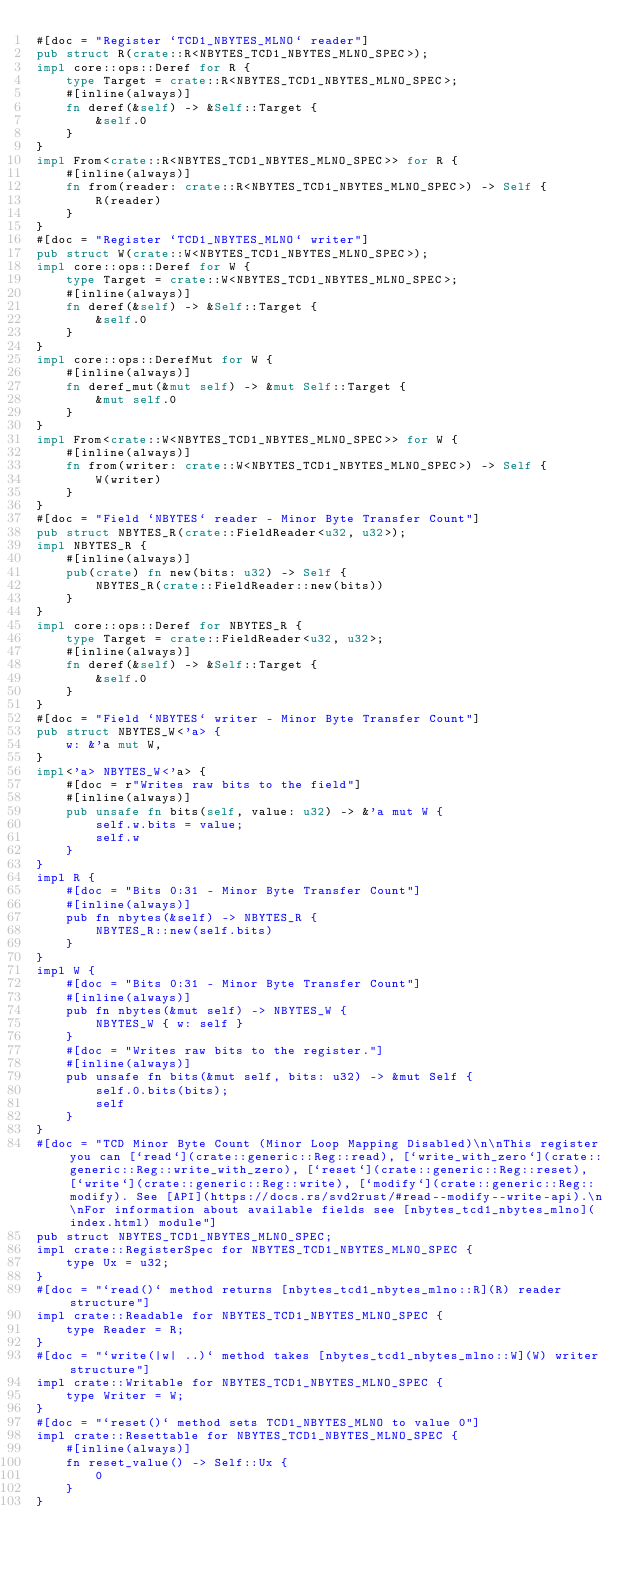Convert code to text. <code><loc_0><loc_0><loc_500><loc_500><_Rust_>#[doc = "Register `TCD1_NBYTES_MLNO` reader"]
pub struct R(crate::R<NBYTES_TCD1_NBYTES_MLNO_SPEC>);
impl core::ops::Deref for R {
    type Target = crate::R<NBYTES_TCD1_NBYTES_MLNO_SPEC>;
    #[inline(always)]
    fn deref(&self) -> &Self::Target {
        &self.0
    }
}
impl From<crate::R<NBYTES_TCD1_NBYTES_MLNO_SPEC>> for R {
    #[inline(always)]
    fn from(reader: crate::R<NBYTES_TCD1_NBYTES_MLNO_SPEC>) -> Self {
        R(reader)
    }
}
#[doc = "Register `TCD1_NBYTES_MLNO` writer"]
pub struct W(crate::W<NBYTES_TCD1_NBYTES_MLNO_SPEC>);
impl core::ops::Deref for W {
    type Target = crate::W<NBYTES_TCD1_NBYTES_MLNO_SPEC>;
    #[inline(always)]
    fn deref(&self) -> &Self::Target {
        &self.0
    }
}
impl core::ops::DerefMut for W {
    #[inline(always)]
    fn deref_mut(&mut self) -> &mut Self::Target {
        &mut self.0
    }
}
impl From<crate::W<NBYTES_TCD1_NBYTES_MLNO_SPEC>> for W {
    #[inline(always)]
    fn from(writer: crate::W<NBYTES_TCD1_NBYTES_MLNO_SPEC>) -> Self {
        W(writer)
    }
}
#[doc = "Field `NBYTES` reader - Minor Byte Transfer Count"]
pub struct NBYTES_R(crate::FieldReader<u32, u32>);
impl NBYTES_R {
    #[inline(always)]
    pub(crate) fn new(bits: u32) -> Self {
        NBYTES_R(crate::FieldReader::new(bits))
    }
}
impl core::ops::Deref for NBYTES_R {
    type Target = crate::FieldReader<u32, u32>;
    #[inline(always)]
    fn deref(&self) -> &Self::Target {
        &self.0
    }
}
#[doc = "Field `NBYTES` writer - Minor Byte Transfer Count"]
pub struct NBYTES_W<'a> {
    w: &'a mut W,
}
impl<'a> NBYTES_W<'a> {
    #[doc = r"Writes raw bits to the field"]
    #[inline(always)]
    pub unsafe fn bits(self, value: u32) -> &'a mut W {
        self.w.bits = value;
        self.w
    }
}
impl R {
    #[doc = "Bits 0:31 - Minor Byte Transfer Count"]
    #[inline(always)]
    pub fn nbytes(&self) -> NBYTES_R {
        NBYTES_R::new(self.bits)
    }
}
impl W {
    #[doc = "Bits 0:31 - Minor Byte Transfer Count"]
    #[inline(always)]
    pub fn nbytes(&mut self) -> NBYTES_W {
        NBYTES_W { w: self }
    }
    #[doc = "Writes raw bits to the register."]
    #[inline(always)]
    pub unsafe fn bits(&mut self, bits: u32) -> &mut Self {
        self.0.bits(bits);
        self
    }
}
#[doc = "TCD Minor Byte Count (Minor Loop Mapping Disabled)\n\nThis register you can [`read`](crate::generic::Reg::read), [`write_with_zero`](crate::generic::Reg::write_with_zero), [`reset`](crate::generic::Reg::reset), [`write`](crate::generic::Reg::write), [`modify`](crate::generic::Reg::modify). See [API](https://docs.rs/svd2rust/#read--modify--write-api).\n\nFor information about available fields see [nbytes_tcd1_nbytes_mlno](index.html) module"]
pub struct NBYTES_TCD1_NBYTES_MLNO_SPEC;
impl crate::RegisterSpec for NBYTES_TCD1_NBYTES_MLNO_SPEC {
    type Ux = u32;
}
#[doc = "`read()` method returns [nbytes_tcd1_nbytes_mlno::R](R) reader structure"]
impl crate::Readable for NBYTES_TCD1_NBYTES_MLNO_SPEC {
    type Reader = R;
}
#[doc = "`write(|w| ..)` method takes [nbytes_tcd1_nbytes_mlno::W](W) writer structure"]
impl crate::Writable for NBYTES_TCD1_NBYTES_MLNO_SPEC {
    type Writer = W;
}
#[doc = "`reset()` method sets TCD1_NBYTES_MLNO to value 0"]
impl crate::Resettable for NBYTES_TCD1_NBYTES_MLNO_SPEC {
    #[inline(always)]
    fn reset_value() -> Self::Ux {
        0
    }
}
</code> 